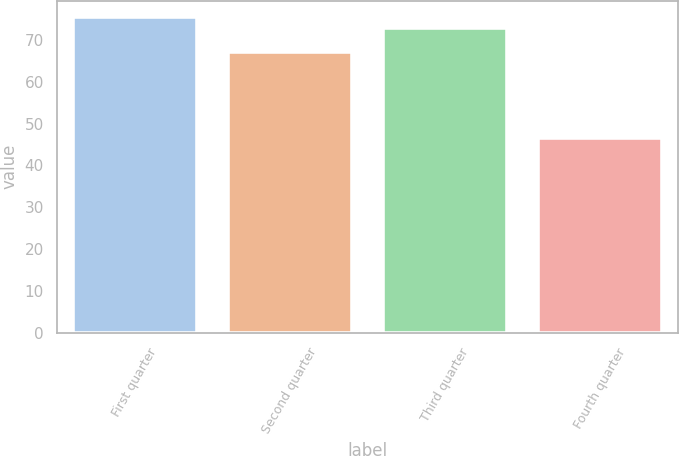<chart> <loc_0><loc_0><loc_500><loc_500><bar_chart><fcel>First quarter<fcel>Second quarter<fcel>Third quarter<fcel>Fourth quarter<nl><fcel>75.59<fcel>67.18<fcel>72.82<fcel>46.49<nl></chart> 